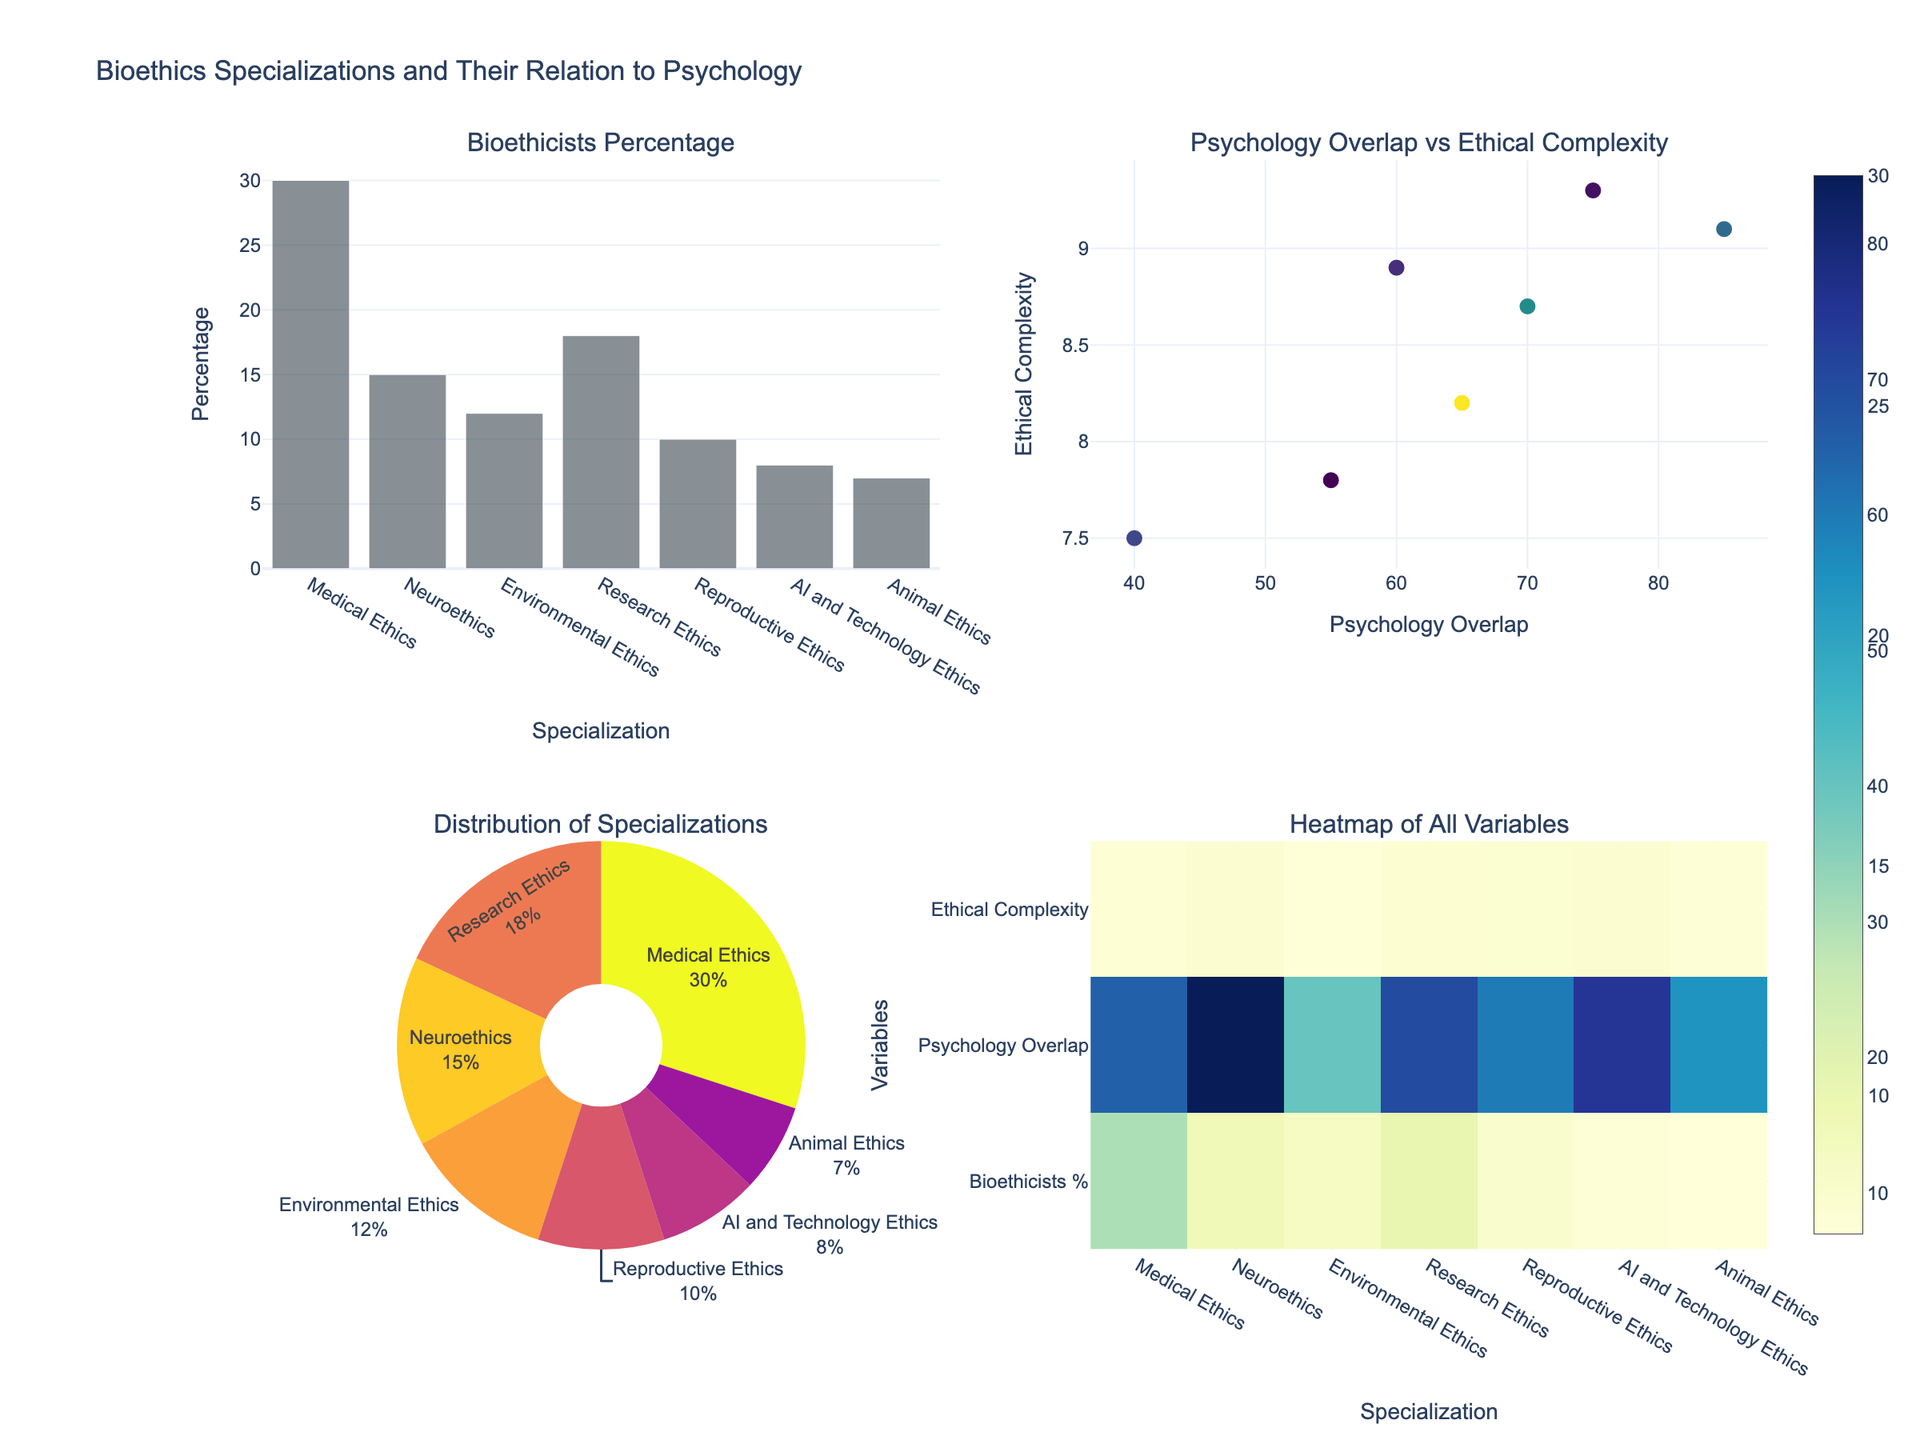What's the percentage of bioethicists focused on Medical Ethics? Refer to the bar chart or the pie chart in the figure where the "Medical Ethics" label indicates the percentage. The bar chart shows 30%, and the same can be confirmed in the pie chart.
Answer: 30% What is the specialization with the highest ethical complexity? Look at the scatter plot, where ethical complexity is mapped on the y-axis, and the specialization with the highest value is "AI and Technology Ethics" at 9.3.
Answer: AI and Technology Ethics Compare the psychology overlap percentages between Neuroethics and Environmental Ethics. Which one is greater? Look at the bar chart or the scatter plot for the psychology overlap percentages. Neuroethics has a higher percentage (85%) compared to Environmental Ethics (40%).
Answer: Neuroethics Which specialization has the least percentage of bioethicists? Refer to the bar chart or pie chart where the specialization with the smallest portion is identified. "Animal Ethics" has the lowest percentage at 7%.
Answer: Animal Ethics What is the average ethical complexity across all specializations? Use the values from the data: (8.2 + 9.1 + 7.5 + 8.7 + 8.9 + 9.3 + 7.8) / 7 = 59.5 / 7 = 8.5
Answer: 8.5 Is there any specialization with a psychology overlap below 50%? Refer to the bar chart or heatmap to identify psychology overlap percentages. "Environmental Ethics" is the only specialization with a psychology overlap of 40%, which is below 50%.
Answer: Environmental Ethics Which specializations fall in the range of 50-70% psychology overlap? Check the scatter plot and bar chart for this range: "Medical Ethics" (65%), "Research Ethics" (70%), "Reproductive Ethics" (60%), and "Animal Ethics" (55%).
Answer: Medical Ethics, Research Ethics, Reproductive Ethics, Animal Ethics What is the correlation between psychology overlap and ethical complexity? This requires assessing the scatter plot where psychology overlap (x-axis) is plotted against ethical complexity (y-axis). The points show a positive correlation, meaning higher psychology overlap tends to align with higher ethical complexity.
Answer: Positive correlation How evenly is the bioethicist distribution spread among the specializations? Look at the pie chart for an overview. The distribution is skewed, with "Medical Ethics" having the largest share and "Animal Ethics" the smallest.
Answer: Skewed distribution 